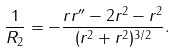Convert formula to latex. <formula><loc_0><loc_0><loc_500><loc_500>\frac { 1 } { R _ { 2 } } = - \frac { r r ^ { \prime \prime } - 2 r ^ { 2 } - r ^ { 2 } } { ( r ^ { 2 } + r ^ { 2 } ) ^ { 3 / 2 } } .</formula> 